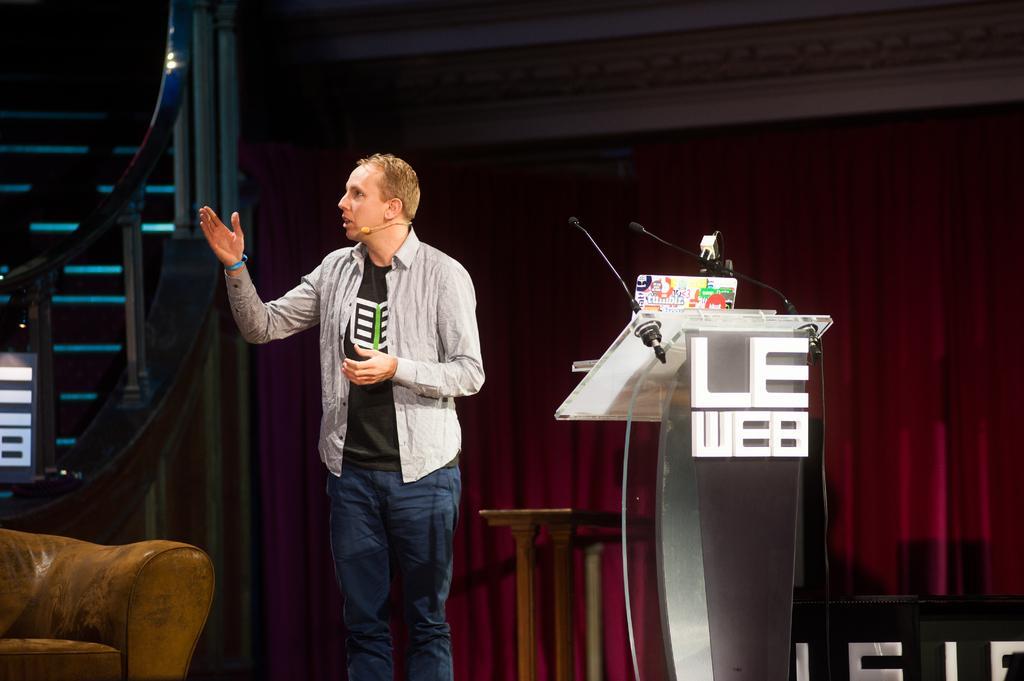In one or two sentences, can you explain what this image depicts? In this image we can see a man standing on the floor wearing a mic. On the right side of the image we can see a podium and a curtain. On the left side of the image we can see a couch and grill. 